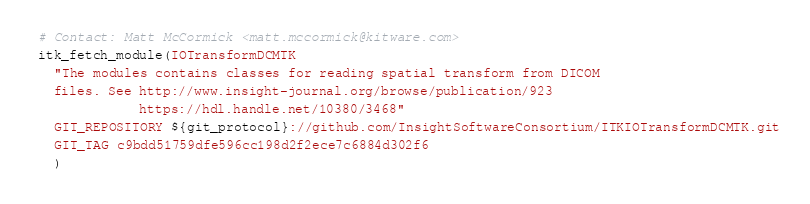Convert code to text. <code><loc_0><loc_0><loc_500><loc_500><_CMake_># Contact: Matt McCormick <matt.mccormick@kitware.com>
itk_fetch_module(IOTransformDCMTK
  "The modules contains classes for reading spatial transform from DICOM
  files. See http://www.insight-journal.org/browse/publication/923
             https://hdl.handle.net/10380/3468"
  GIT_REPOSITORY ${git_protocol}://github.com/InsightSoftwareConsortium/ITKIOTransformDCMTK.git
  GIT_TAG c9bdd51759dfe596cc198d2f2ece7c6884d302f6
  )
</code> 